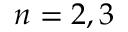Convert formula to latex. <formula><loc_0><loc_0><loc_500><loc_500>n = 2 , 3</formula> 